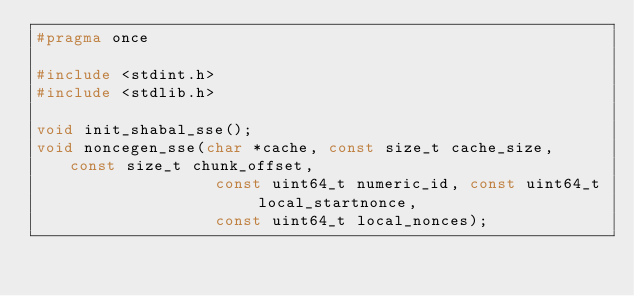Convert code to text. <code><loc_0><loc_0><loc_500><loc_500><_C_>#pragma once

#include <stdint.h>
#include <stdlib.h>

void init_shabal_sse();
void noncegen_sse(char *cache, const size_t cache_size, const size_t chunk_offset,
                   const uint64_t numeric_id, const uint64_t local_startnonce,
                   const uint64_t local_nonces);
</code> 